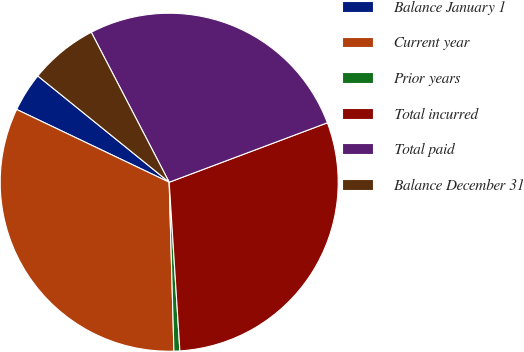<chart> <loc_0><loc_0><loc_500><loc_500><pie_chart><fcel>Balance January 1<fcel>Current year<fcel>Prior years<fcel>Total incurred<fcel>Total paid<fcel>Balance December 31<nl><fcel>3.74%<fcel>32.53%<fcel>0.56%<fcel>29.71%<fcel>26.9%<fcel>6.55%<nl></chart> 